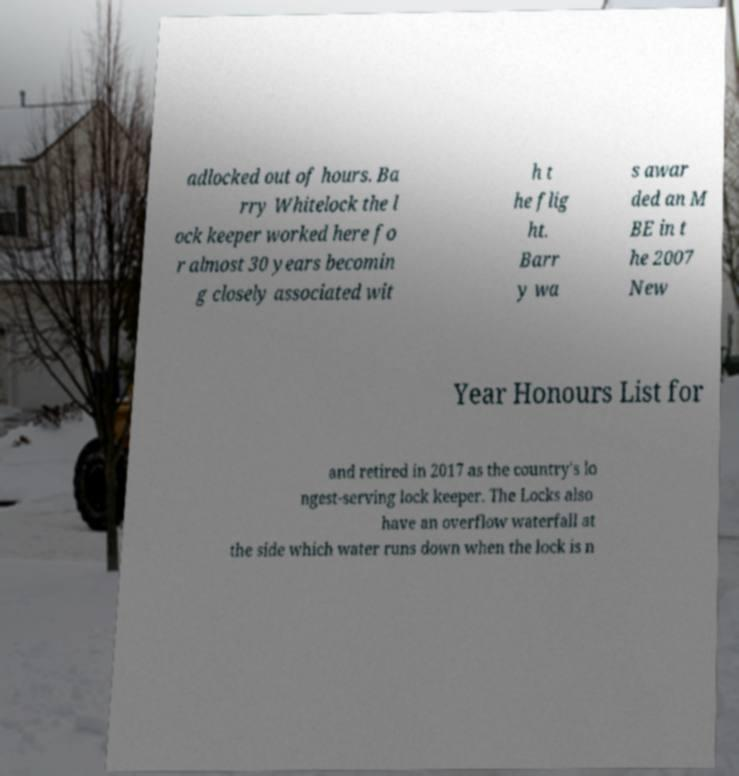There's text embedded in this image that I need extracted. Can you transcribe it verbatim? adlocked out of hours. Ba rry Whitelock the l ock keeper worked here fo r almost 30 years becomin g closely associated wit h t he flig ht. Barr y wa s awar ded an M BE in t he 2007 New Year Honours List for and retired in 2017 as the country's lo ngest-serving lock keeper. The Locks also have an overflow waterfall at the side which water runs down when the lock is n 